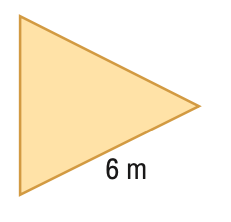Answer the mathemtical geometry problem and directly provide the correct option letter.
Question: Find the area of the regular polygon. Round to the nearest tenth.
Choices: A: 15.6 B: 18.0 C: 31.2 D: 36.0 A 